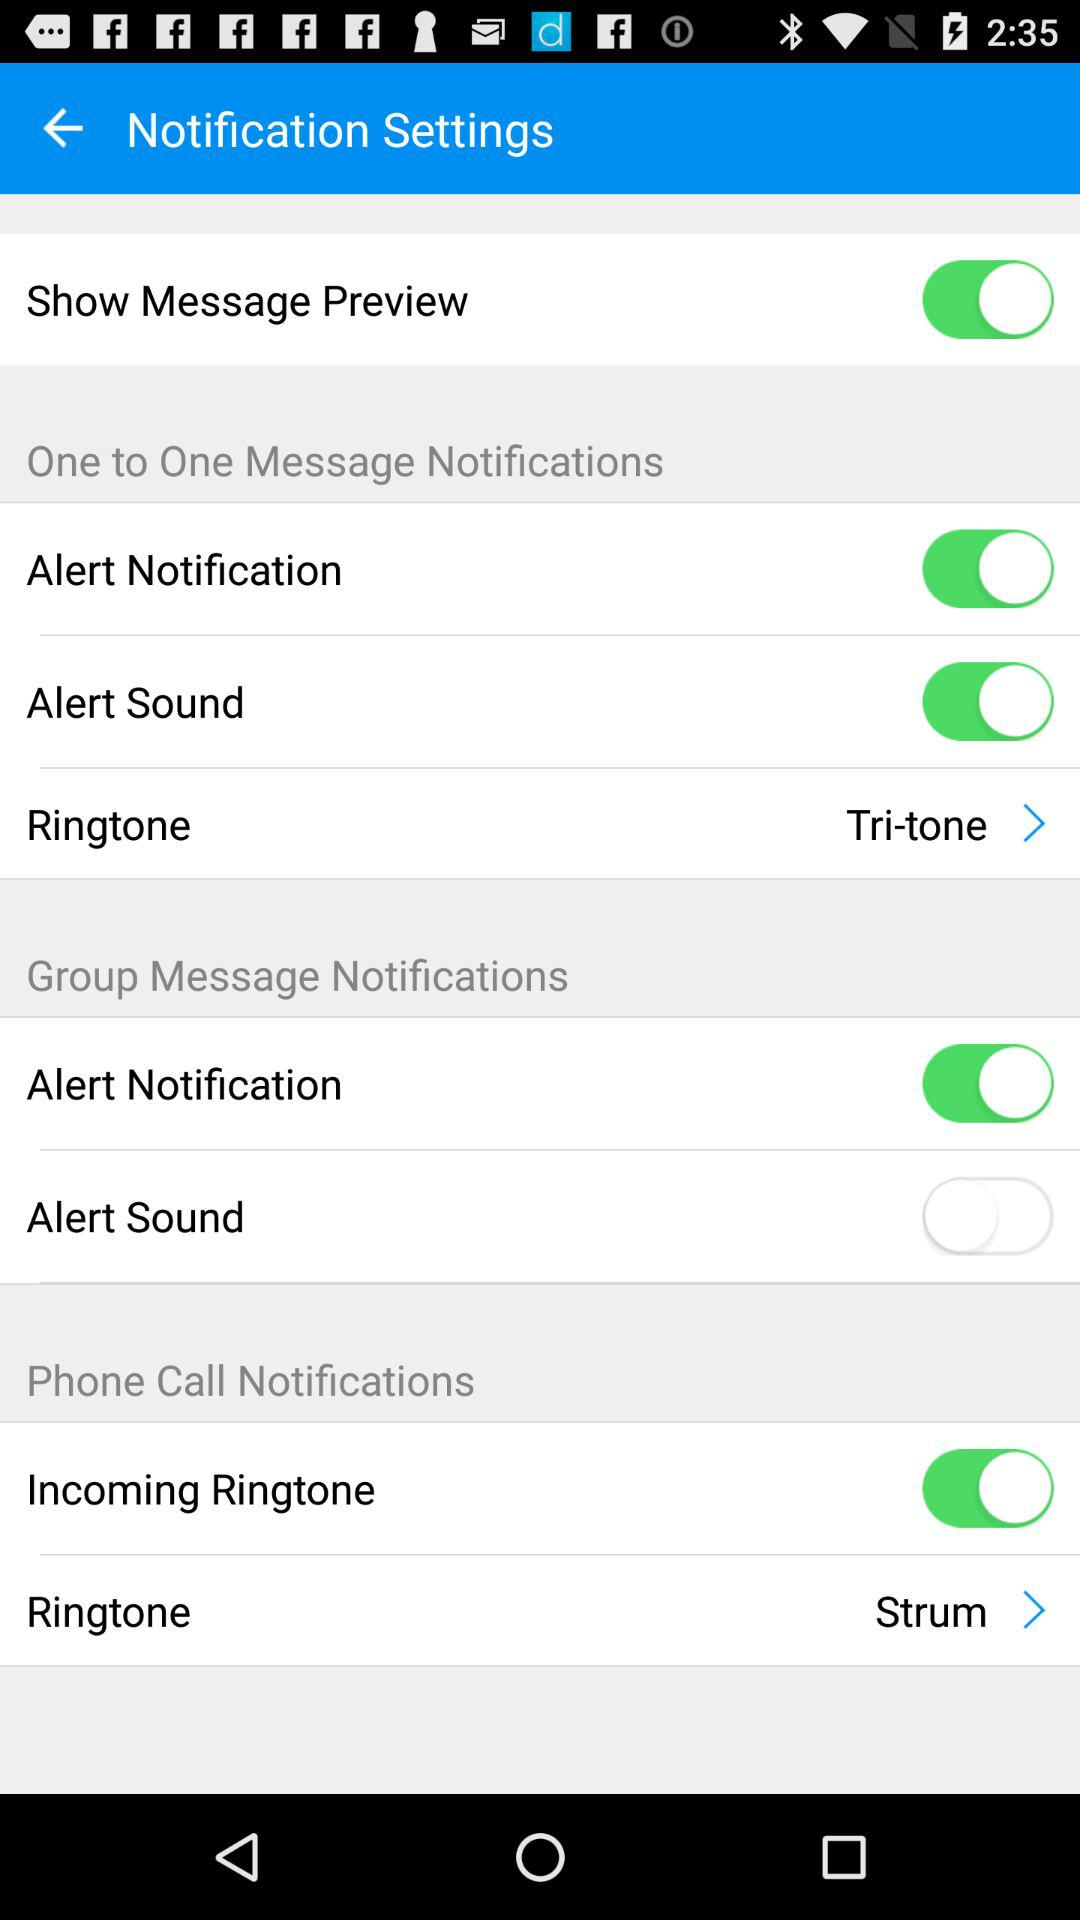What is the status of "Incoming Ringtone"? The status is "on". 